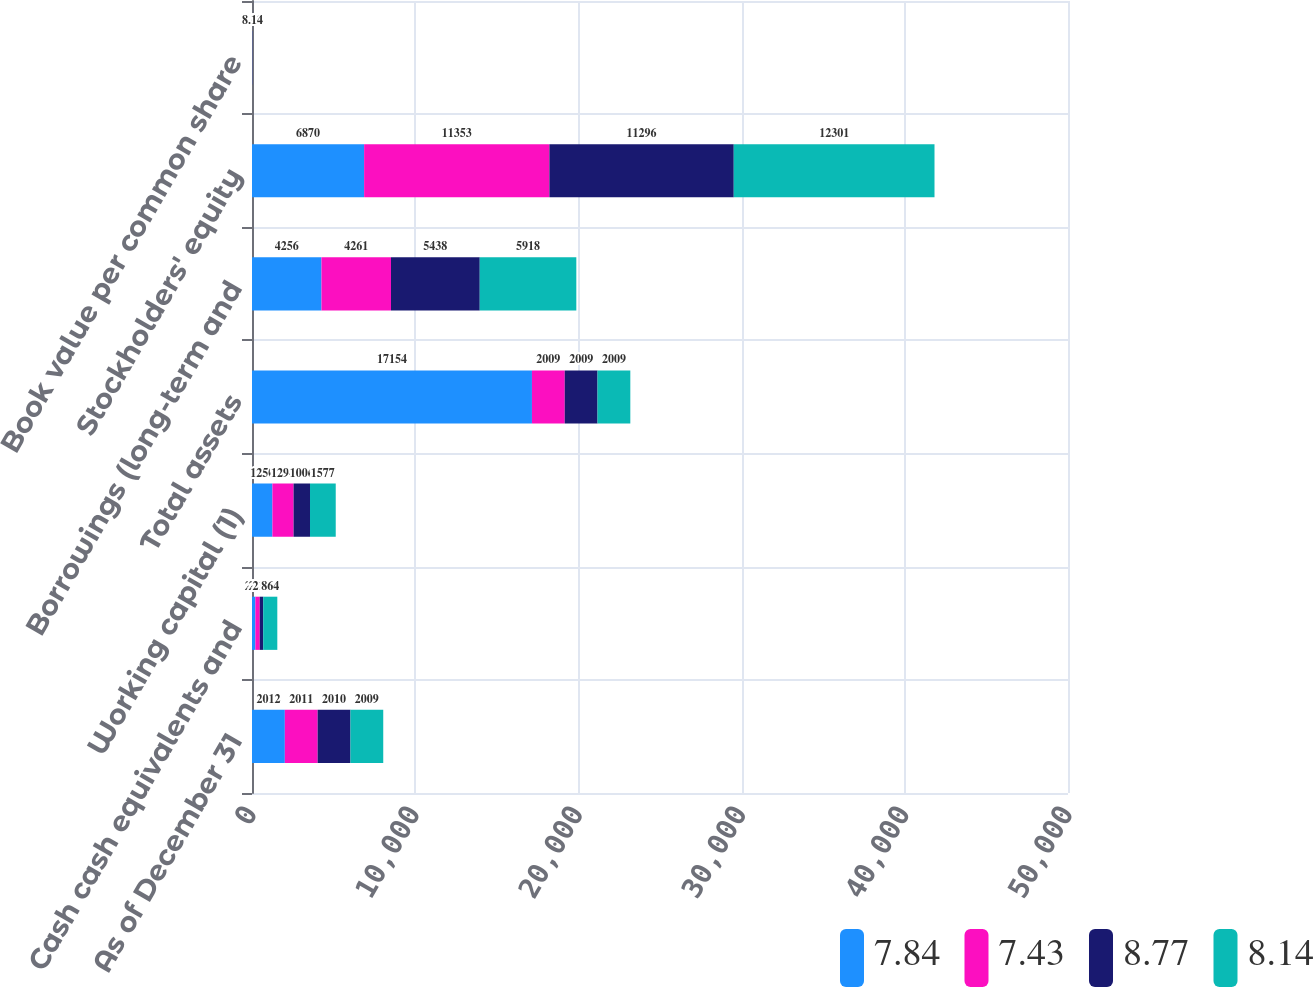<chart> <loc_0><loc_0><loc_500><loc_500><stacked_bar_chart><ecel><fcel>As of December 31<fcel>Cash cash equivalents and<fcel>Working capital (1)<fcel>Total assets<fcel>Borrowings (long-term and<fcel>Stockholders' equity<fcel>Book value per common share<nl><fcel>7.84<fcel>2012<fcel>207<fcel>1250<fcel>17154<fcel>4256<fcel>6870<fcel>5.07<nl><fcel>7.43<fcel>2011<fcel>267<fcel>1298<fcel>2009<fcel>4261<fcel>11353<fcel>7.84<nl><fcel>8.77<fcel>2010<fcel>213<fcel>1006<fcel>2009<fcel>5438<fcel>11296<fcel>7.43<nl><fcel>8.14<fcel>2009<fcel>864<fcel>1577<fcel>2009<fcel>5918<fcel>12301<fcel>8.14<nl></chart> 